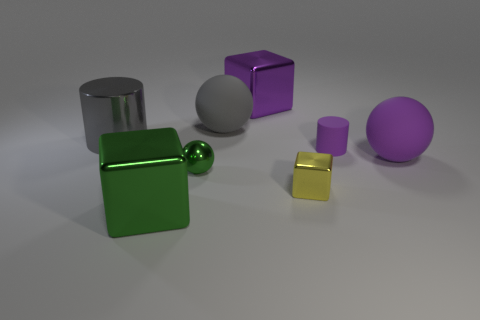Add 1 yellow objects. How many objects exist? 9 Subtract all cylinders. How many objects are left? 6 Add 7 gray cylinders. How many gray cylinders exist? 8 Subtract 0 yellow cylinders. How many objects are left? 8 Subtract all purple things. Subtract all yellow metal cylinders. How many objects are left? 5 Add 6 yellow blocks. How many yellow blocks are left? 7 